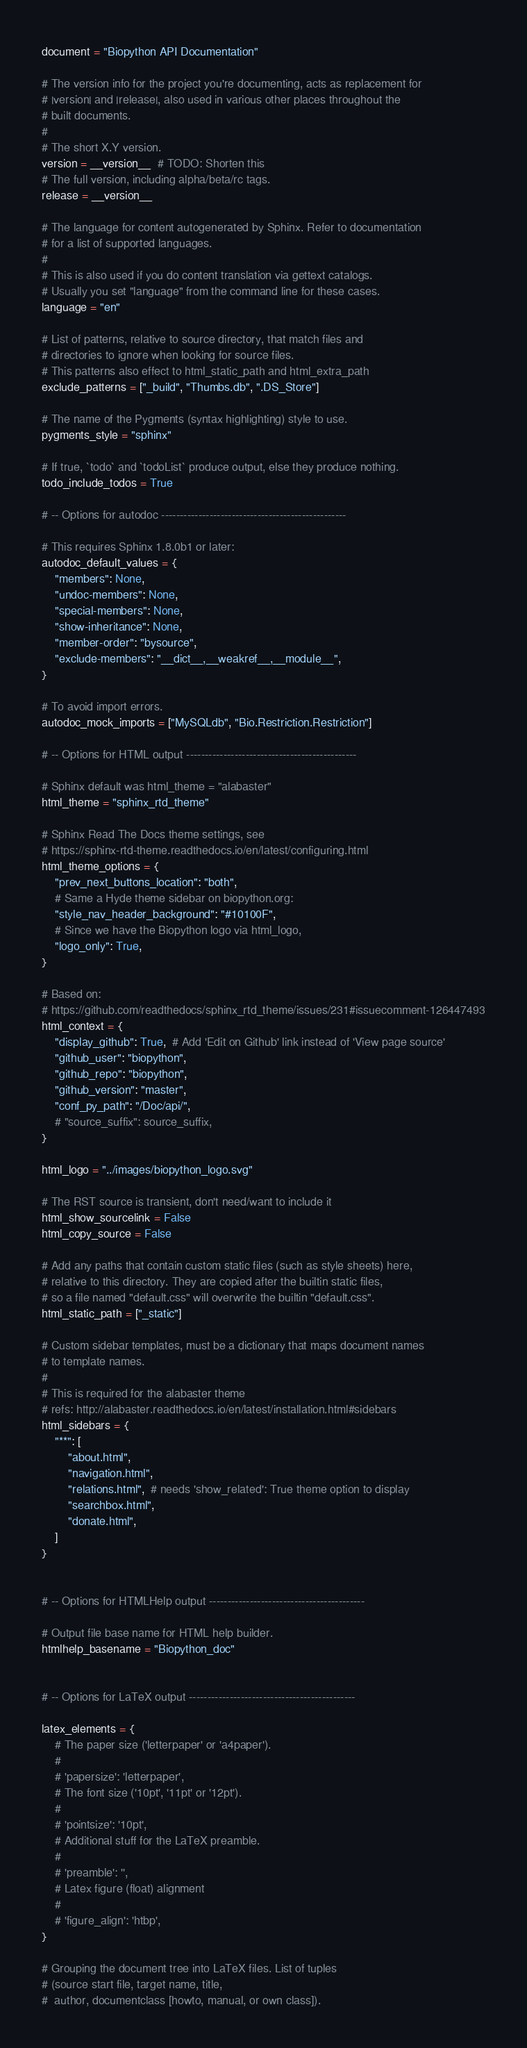<code> <loc_0><loc_0><loc_500><loc_500><_Python_>document = "Biopython API Documentation"

# The version info for the project you're documenting, acts as replacement for
# |version| and |release|, also used in various other places throughout the
# built documents.
#
# The short X.Y version.
version = __version__  # TODO: Shorten this
# The full version, including alpha/beta/rc tags.
release = __version__

# The language for content autogenerated by Sphinx. Refer to documentation
# for a list of supported languages.
#
# This is also used if you do content translation via gettext catalogs.
# Usually you set "language" from the command line for these cases.
language = "en"

# List of patterns, relative to source directory, that match files and
# directories to ignore when looking for source files.
# This patterns also effect to html_static_path and html_extra_path
exclude_patterns = ["_build", "Thumbs.db", ".DS_Store"]

# The name of the Pygments (syntax highlighting) style to use.
pygments_style = "sphinx"

# If true, `todo` and `todoList` produce output, else they produce nothing.
todo_include_todos = True

# -- Options for autodoc --------------------------------------------------

# This requires Sphinx 1.8.0b1 or later:
autodoc_default_values = {
    "members": None,
    "undoc-members": None,
    "special-members": None,
    "show-inheritance": None,
    "member-order": "bysource",
    "exclude-members": "__dict__,__weakref__,__module__",
}

# To avoid import errors.
autodoc_mock_imports = ["MySQLdb", "Bio.Restriction.Restriction"]

# -- Options for HTML output ----------------------------------------------

# Sphinx default was html_theme = "alabaster"
html_theme = "sphinx_rtd_theme"

# Sphinx Read The Docs theme settings, see
# https://sphinx-rtd-theme.readthedocs.io/en/latest/configuring.html
html_theme_options = {
    "prev_next_buttons_location": "both",
    # Same a Hyde theme sidebar on biopython.org:
    "style_nav_header_background": "#10100F",
    # Since we have the Biopython logo via html_logo,
    "logo_only": True,
}

# Based on:
# https://github.com/readthedocs/sphinx_rtd_theme/issues/231#issuecomment-126447493
html_context = {
    "display_github": True,  # Add 'Edit on Github' link instead of 'View page source'
    "github_user": "biopython",
    "github_repo": "biopython",
    "github_version": "master",
    "conf_py_path": "/Doc/api/",
    # "source_suffix": source_suffix,
}

html_logo = "../images/biopython_logo.svg"

# The RST source is transient, don't need/want to include it
html_show_sourcelink = False
html_copy_source = False

# Add any paths that contain custom static files (such as style sheets) here,
# relative to this directory. They are copied after the builtin static files,
# so a file named "default.css" will overwrite the builtin "default.css".
html_static_path = ["_static"]

# Custom sidebar templates, must be a dictionary that maps document names
# to template names.
#
# This is required for the alabaster theme
# refs: http://alabaster.readthedocs.io/en/latest/installation.html#sidebars
html_sidebars = {
    "**": [
        "about.html",
        "navigation.html",
        "relations.html",  # needs 'show_related': True theme option to display
        "searchbox.html",
        "donate.html",
    ]
}


# -- Options for HTMLHelp output ------------------------------------------

# Output file base name for HTML help builder.
htmlhelp_basename = "Biopython_doc"


# -- Options for LaTeX output ---------------------------------------------

latex_elements = {
    # The paper size ('letterpaper' or 'a4paper').
    #
    # 'papersize': 'letterpaper',
    # The font size ('10pt', '11pt' or '12pt').
    #
    # 'pointsize': '10pt',
    # Additional stuff for the LaTeX preamble.
    #
    # 'preamble': '',
    # Latex figure (float) alignment
    #
    # 'figure_align': 'htbp',
}

# Grouping the document tree into LaTeX files. List of tuples
# (source start file, target name, title,
#  author, documentclass [howto, manual, or own class]).</code> 